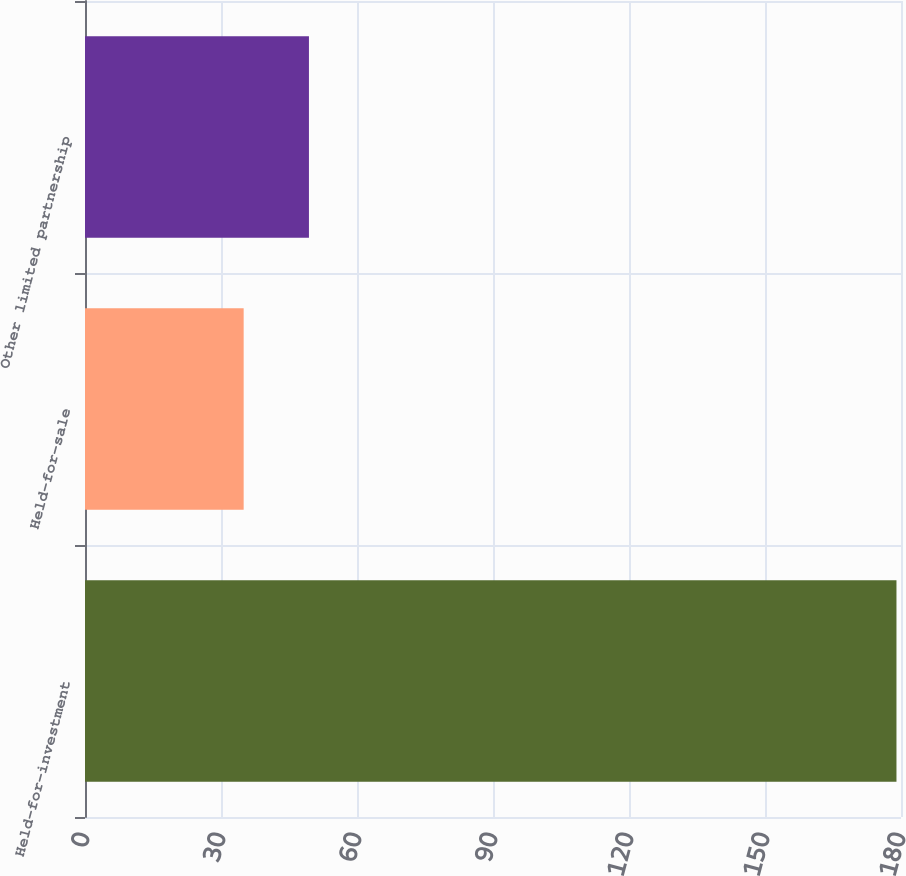Convert chart. <chart><loc_0><loc_0><loc_500><loc_500><bar_chart><fcel>Held-for-investment<fcel>Held-for-sale<fcel>Other limited partnership<nl><fcel>179<fcel>35<fcel>49.4<nl></chart> 